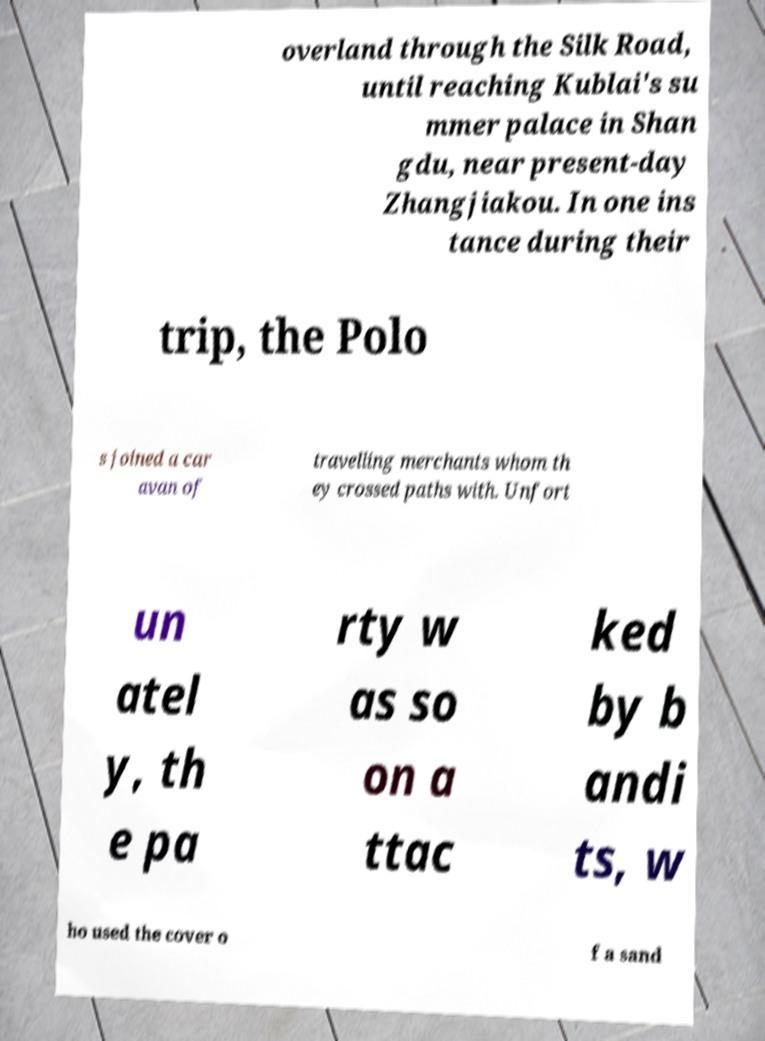Can you read and provide the text displayed in the image?This photo seems to have some interesting text. Can you extract and type it out for me? overland through the Silk Road, until reaching Kublai's su mmer palace in Shan gdu, near present-day Zhangjiakou. In one ins tance during their trip, the Polo s joined a car avan of travelling merchants whom th ey crossed paths with. Unfort un atel y, th e pa rty w as so on a ttac ked by b andi ts, w ho used the cover o f a sand 